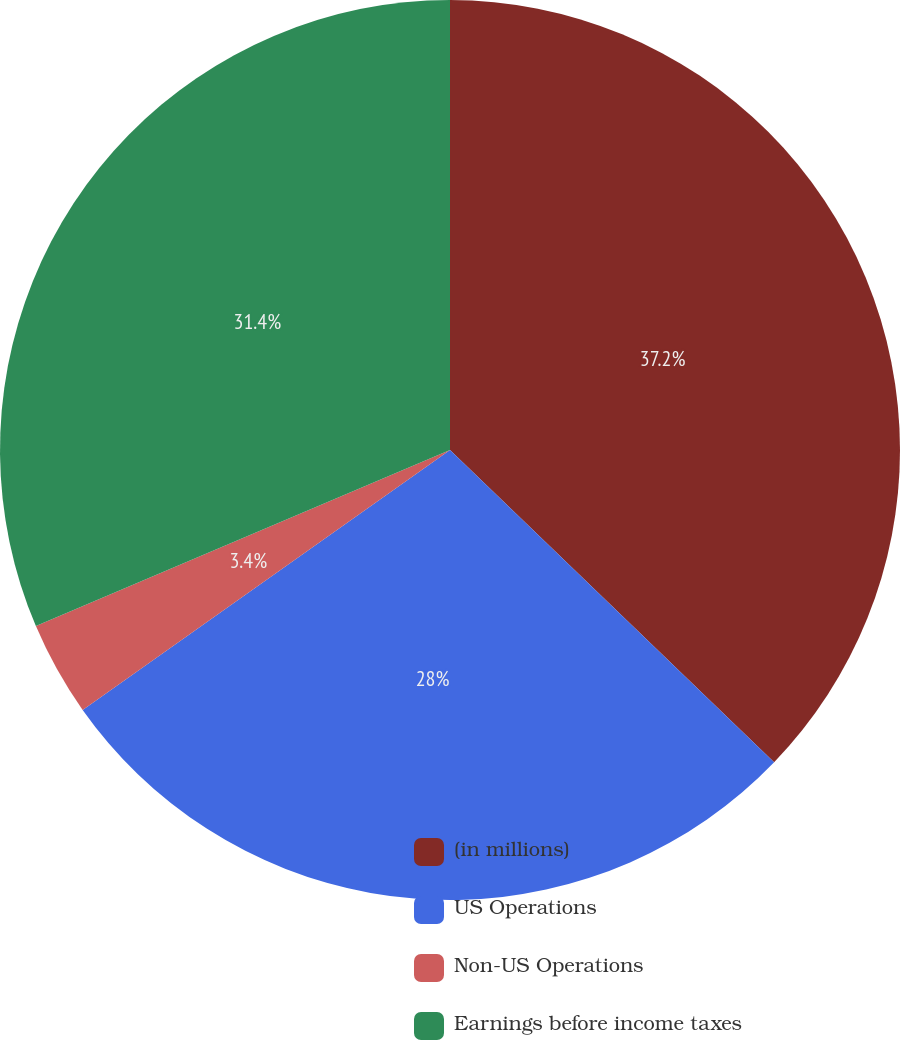<chart> <loc_0><loc_0><loc_500><loc_500><pie_chart><fcel>(in millions)<fcel>US Operations<fcel>Non-US Operations<fcel>Earnings before income taxes<nl><fcel>37.2%<fcel>28.0%<fcel>3.4%<fcel>31.4%<nl></chart> 